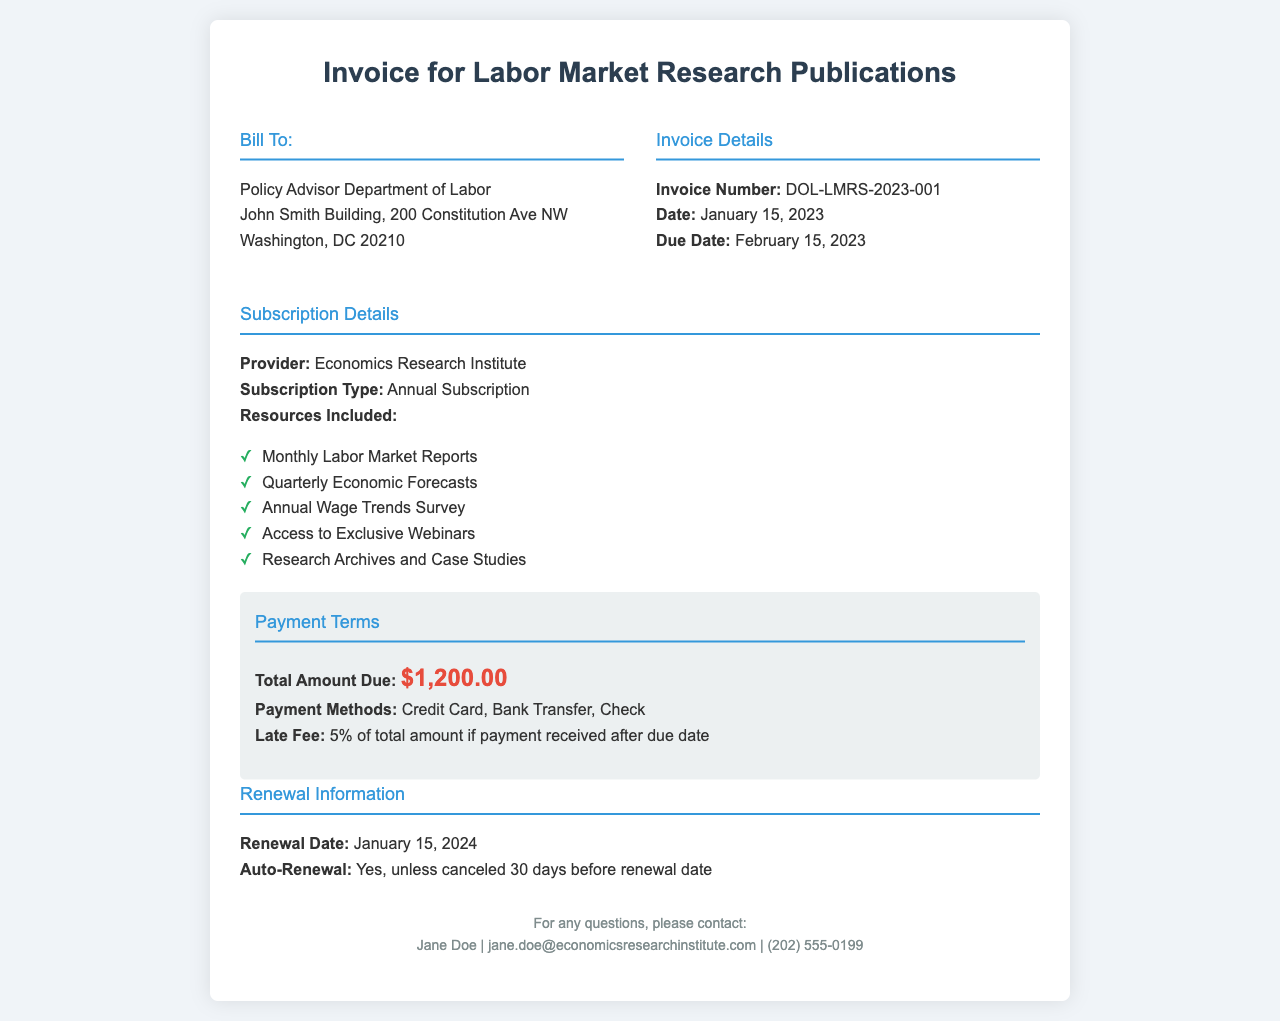What is the invoice number? The invoice number can be found in the invoice details section.
Answer: DOL-LMRS-2023-001 What is the total amount due? The total amount due is mentioned in the payment terms section of the invoice.
Answer: $1,200.00 What are the payment methods available? The payment methods can be found in the payment terms section.
Answer: Credit Card, Bank Transfer, Check When is the due date for payment? The due date is specified in the invoice details section.
Answer: February 15, 2023 What is the renewal date? The renewal date is provided in the renewal information section of the invoice.
Answer: January 15, 2024 How many resources are included in the subscription? The resources included are listed in the subscription details section and counted.
Answer: Five What will happen if payment is received after the due date? The consequences of late payment are outlined in the payment terms section.
Answer: 5% of total amount What type of subscription is being invoiced? The subscription type is described in the subscription details section.
Answer: Annual Subscription 